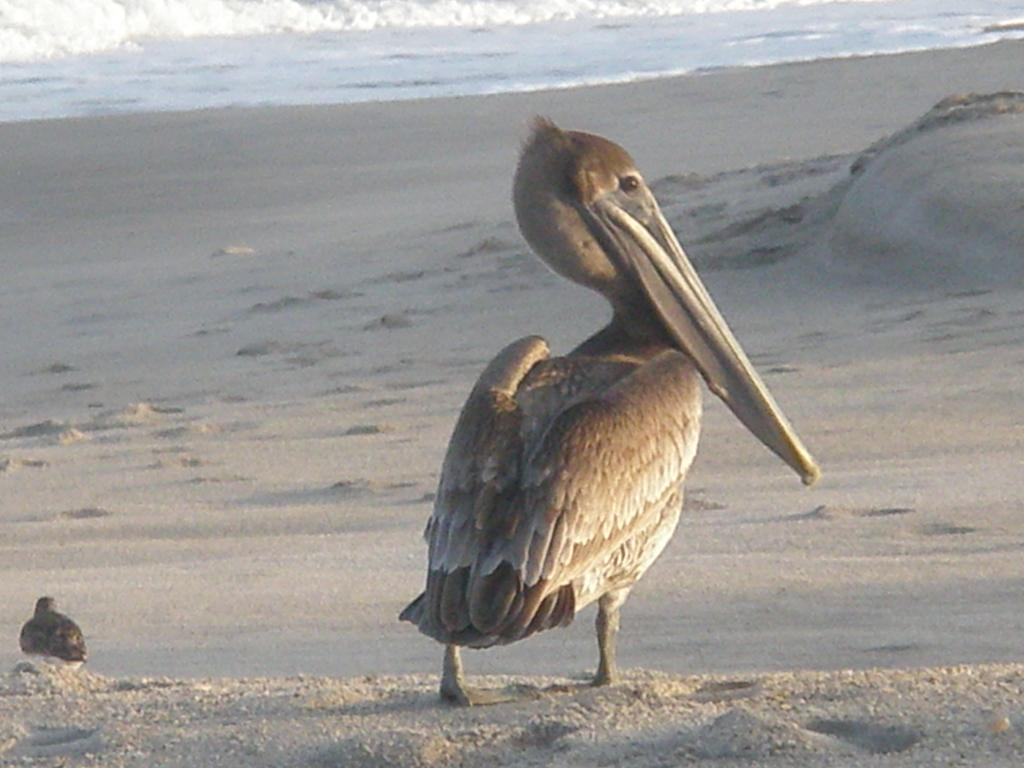How many birds can be seen in the image? There are two birds in the image. What type of surface are the birds on? The birds are on a sand surface. What can be seen in the background of the image? There are tides of an ocean in the background of the image. What type of haircut does the bird on the left have in the image? There is no indication of a haircut on the birds in the image, as birds do not have hair. 